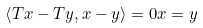Convert formula to latex. <formula><loc_0><loc_0><loc_500><loc_500>\left \langle T x - T y , x - y \right \rangle = 0 x = y</formula> 